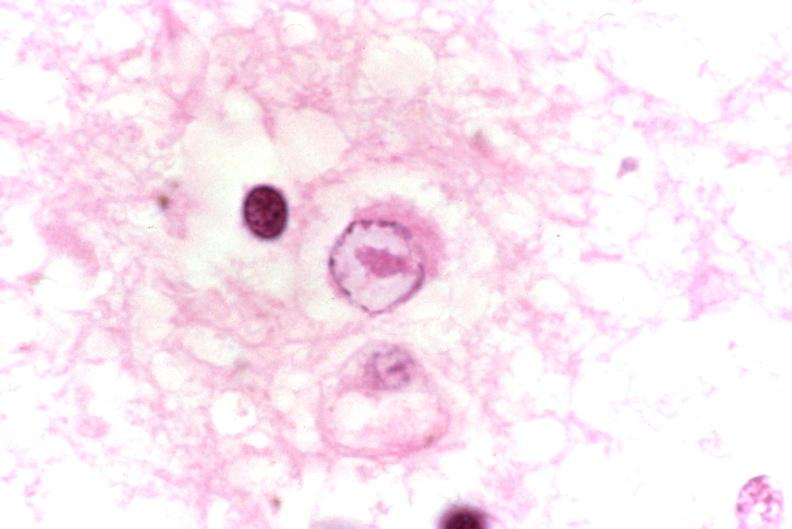what is present?
Answer the question using a single word or phrase. Nervous 